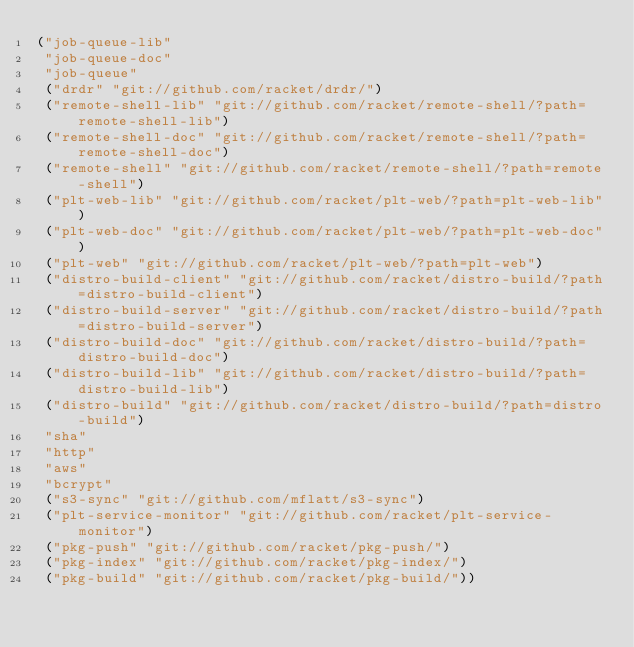<code> <loc_0><loc_0><loc_500><loc_500><_Racket_>("job-queue-lib"
 "job-queue-doc"
 "job-queue"
 ("drdr" "git://github.com/racket/drdr/")
 ("remote-shell-lib" "git://github.com/racket/remote-shell/?path=remote-shell-lib")
 ("remote-shell-doc" "git://github.com/racket/remote-shell/?path=remote-shell-doc")
 ("remote-shell" "git://github.com/racket/remote-shell/?path=remote-shell")
 ("plt-web-lib" "git://github.com/racket/plt-web/?path=plt-web-lib")
 ("plt-web-doc" "git://github.com/racket/plt-web/?path=plt-web-doc")
 ("plt-web" "git://github.com/racket/plt-web/?path=plt-web")
 ("distro-build-client" "git://github.com/racket/distro-build/?path=distro-build-client")
 ("distro-build-server" "git://github.com/racket/distro-build/?path=distro-build-server")
 ("distro-build-doc" "git://github.com/racket/distro-build/?path=distro-build-doc")
 ("distro-build-lib" "git://github.com/racket/distro-build/?path=distro-build-lib")
 ("distro-build" "git://github.com/racket/distro-build/?path=distro-build")
 "sha"
 "http"
 "aws"
 "bcrypt"
 ("s3-sync" "git://github.com/mflatt/s3-sync")
 ("plt-service-monitor" "git://github.com/racket/plt-service-monitor")
 ("pkg-push" "git://github.com/racket/pkg-push/")
 ("pkg-index" "git://github.com/racket/pkg-index/")
 ("pkg-build" "git://github.com/racket/pkg-build/"))
</code> 